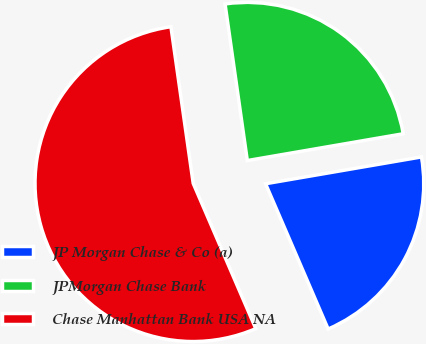Convert chart. <chart><loc_0><loc_0><loc_500><loc_500><pie_chart><fcel>JP Morgan Chase & Co (a)<fcel>JPMorgan Chase Bank<fcel>Chase Manhattan Bank USA NA<nl><fcel>21.24%<fcel>24.54%<fcel>54.23%<nl></chart> 